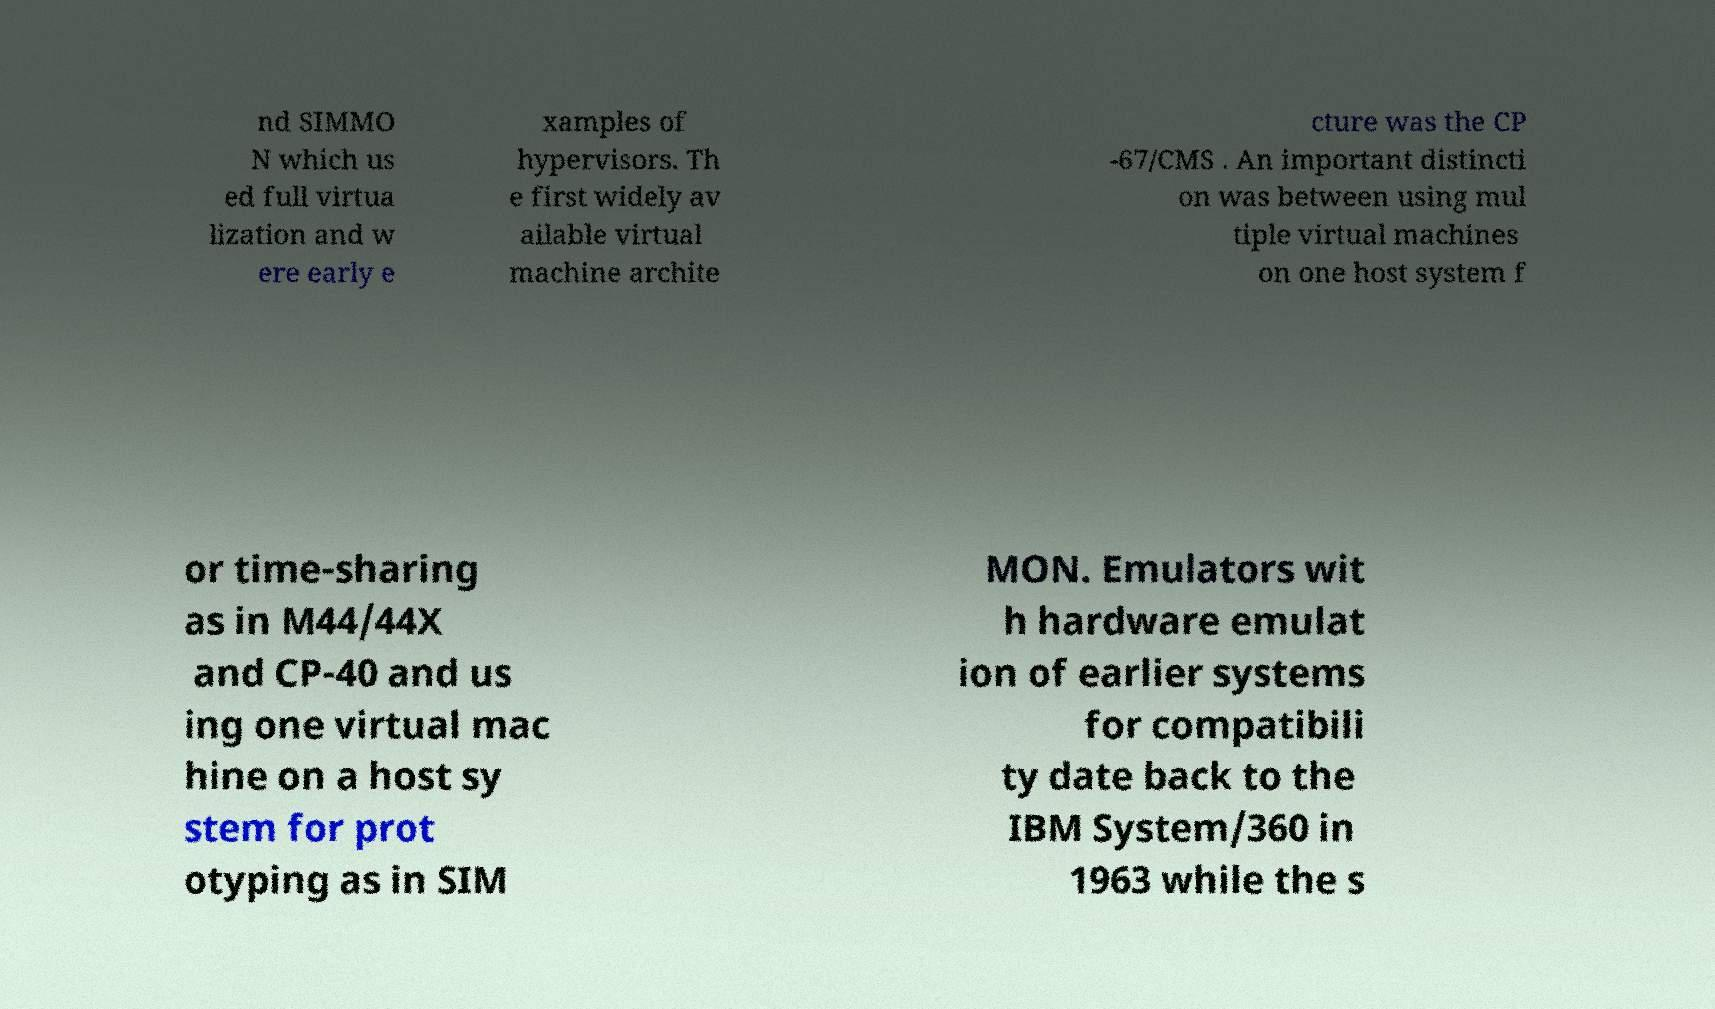Please read and relay the text visible in this image. What does it say? nd SIMMO N which us ed full virtua lization and w ere early e xamples of hypervisors. Th e first widely av ailable virtual machine archite cture was the CP -67/CMS . An important distincti on was between using mul tiple virtual machines on one host system f or time-sharing as in M44/44X and CP-40 and us ing one virtual mac hine on a host sy stem for prot otyping as in SIM MON. Emulators wit h hardware emulat ion of earlier systems for compatibili ty date back to the IBM System/360 in 1963 while the s 